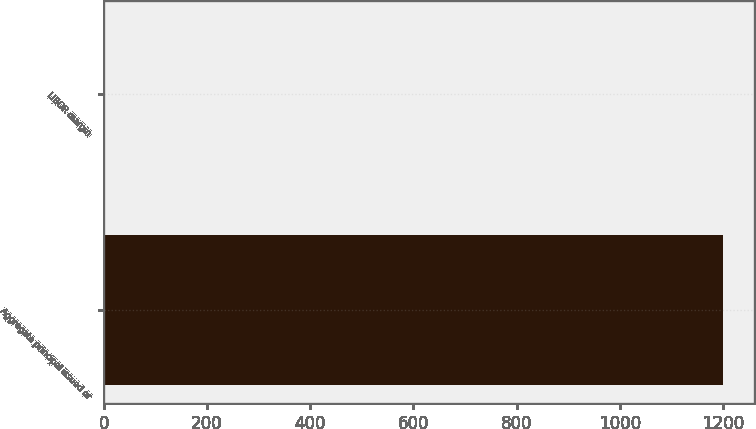Convert chart to OTSL. <chart><loc_0><loc_0><loc_500><loc_500><bar_chart><fcel>Aggregate principal issued or<fcel>LIBOR margin<nl><fcel>1200<fcel>2.25<nl></chart> 